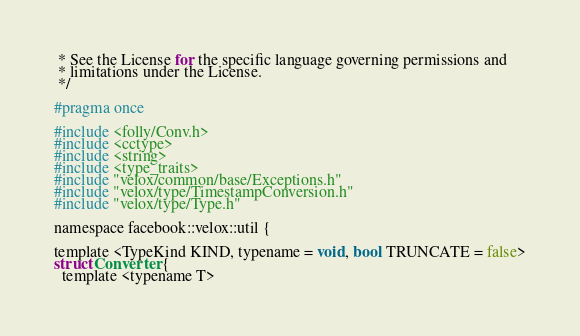Convert code to text. <code><loc_0><loc_0><loc_500><loc_500><_C_> * See the License for the specific language governing permissions and
 * limitations under the License.
 */

#pragma once

#include <folly/Conv.h>
#include <cctype>
#include <string>
#include <type_traits>
#include "velox/common/base/Exceptions.h"
#include "velox/type/TimestampConversion.h"
#include "velox/type/Type.h"

namespace facebook::velox::util {

template <TypeKind KIND, typename = void, bool TRUNCATE = false>
struct Converter {
  template <typename T></code> 